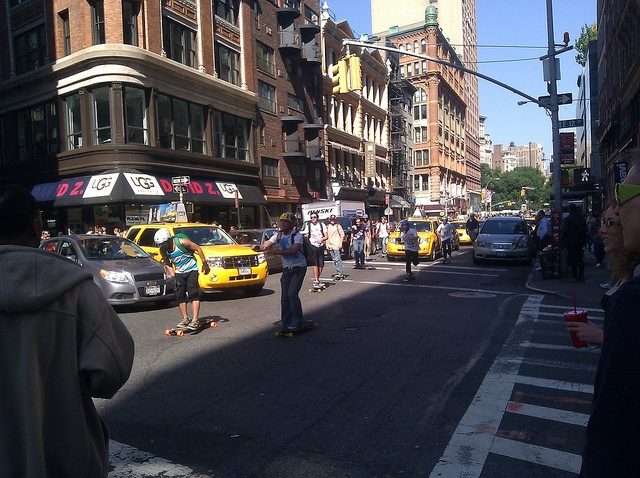Describe the objects in this image and their specific colors. I can see people in black, gray, and darkblue tones, people in black and gray tones, car in black, gray, darkgray, and lightgray tones, car in black, khaki, gold, and maroon tones, and people in black, gray, and white tones in this image. 